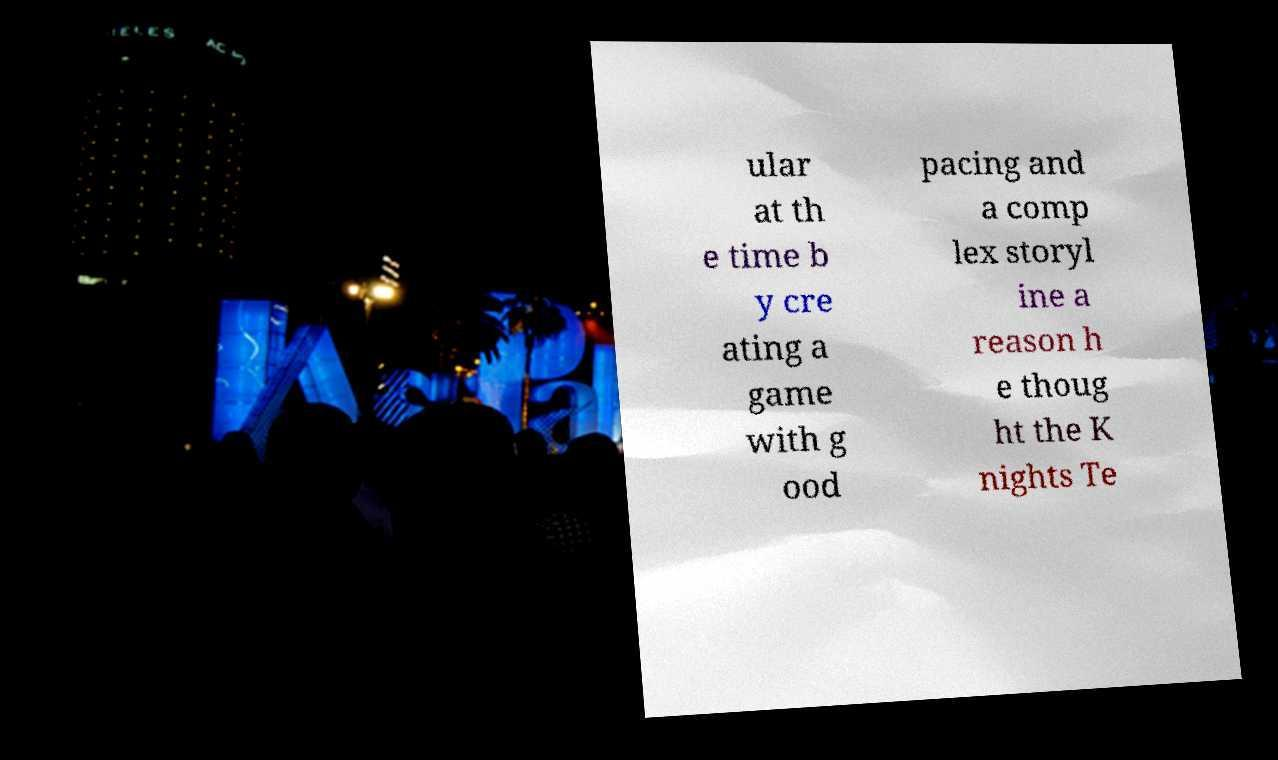There's text embedded in this image that I need extracted. Can you transcribe it verbatim? ular at th e time b y cre ating a game with g ood pacing and a comp lex storyl ine a reason h e thoug ht the K nights Te 